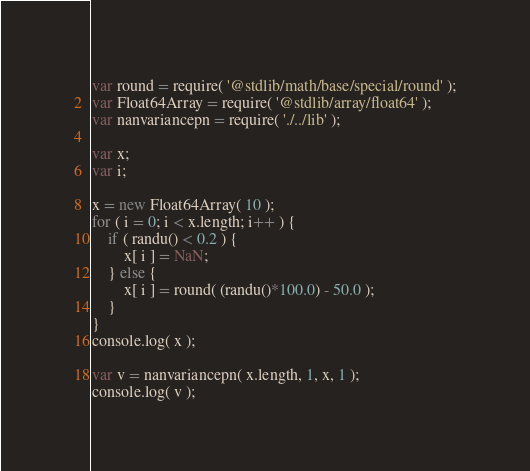<code> <loc_0><loc_0><loc_500><loc_500><_JavaScript_>var round = require( '@stdlib/math/base/special/round' );
var Float64Array = require( '@stdlib/array/float64' );
var nanvariancepn = require( './../lib' );

var x;
var i;

x = new Float64Array( 10 );
for ( i = 0; i < x.length; i++ ) {
	if ( randu() < 0.2 ) {
		x[ i ] = NaN;
	} else {
		x[ i ] = round( (randu()*100.0) - 50.0 );
	}
}
console.log( x );

var v = nanvariancepn( x.length, 1, x, 1 );
console.log( v );
</code> 